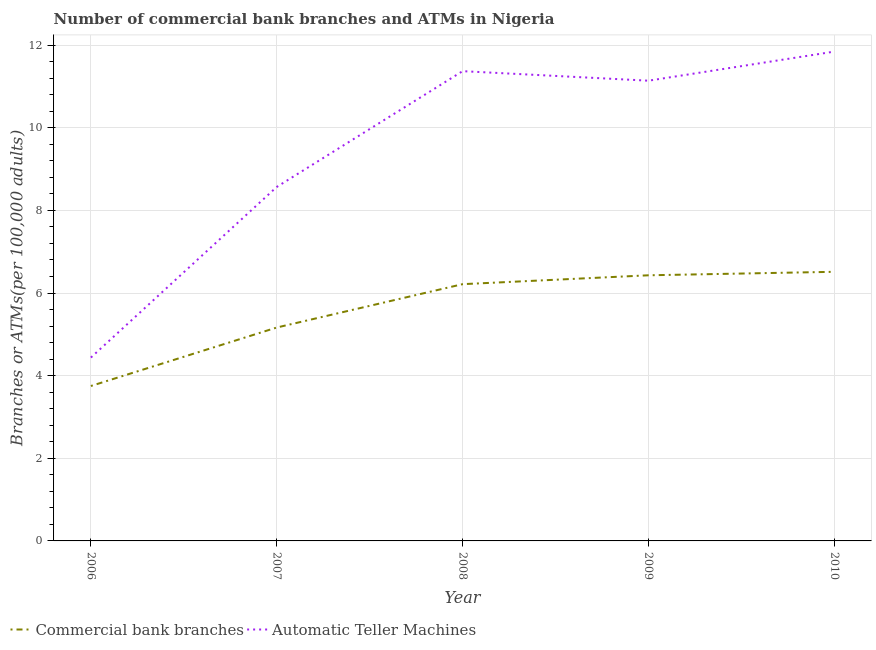Does the line corresponding to number of commercal bank branches intersect with the line corresponding to number of atms?
Offer a very short reply. No. What is the number of atms in 2006?
Your response must be concise. 4.44. Across all years, what is the maximum number of commercal bank branches?
Ensure brevity in your answer.  6.51. Across all years, what is the minimum number of commercal bank branches?
Make the answer very short. 3.75. In which year was the number of atms maximum?
Give a very brief answer. 2010. What is the total number of atms in the graph?
Your response must be concise. 47.36. What is the difference between the number of commercal bank branches in 2009 and that in 2010?
Provide a succinct answer. -0.08. What is the difference between the number of commercal bank branches in 2006 and the number of atms in 2008?
Make the answer very short. -7.62. What is the average number of atms per year?
Provide a succinct answer. 9.47. In the year 2007, what is the difference between the number of atms and number of commercal bank branches?
Ensure brevity in your answer.  3.4. What is the ratio of the number of commercal bank branches in 2007 to that in 2010?
Your response must be concise. 0.79. Is the difference between the number of atms in 2007 and 2009 greater than the difference between the number of commercal bank branches in 2007 and 2009?
Your answer should be compact. No. What is the difference between the highest and the second highest number of atms?
Your response must be concise. 0.47. What is the difference between the highest and the lowest number of atms?
Provide a short and direct response. 7.41. In how many years, is the number of commercal bank branches greater than the average number of commercal bank branches taken over all years?
Offer a very short reply. 3. Is the sum of the number of commercal bank branches in 2007 and 2008 greater than the maximum number of atms across all years?
Keep it short and to the point. No. Does the number of atms monotonically increase over the years?
Give a very brief answer. No. How many years are there in the graph?
Your answer should be very brief. 5. What is the difference between two consecutive major ticks on the Y-axis?
Provide a succinct answer. 2. How many legend labels are there?
Give a very brief answer. 2. How are the legend labels stacked?
Keep it short and to the point. Horizontal. What is the title of the graph?
Provide a short and direct response. Number of commercial bank branches and ATMs in Nigeria. What is the label or title of the Y-axis?
Offer a very short reply. Branches or ATMs(per 100,0 adults). What is the Branches or ATMs(per 100,000 adults) in Commercial bank branches in 2006?
Ensure brevity in your answer.  3.75. What is the Branches or ATMs(per 100,000 adults) in Automatic Teller Machines in 2006?
Offer a terse response. 4.44. What is the Branches or ATMs(per 100,000 adults) of Commercial bank branches in 2007?
Provide a short and direct response. 5.16. What is the Branches or ATMs(per 100,000 adults) in Automatic Teller Machines in 2007?
Offer a terse response. 8.57. What is the Branches or ATMs(per 100,000 adults) in Commercial bank branches in 2008?
Offer a very short reply. 6.21. What is the Branches or ATMs(per 100,000 adults) of Automatic Teller Machines in 2008?
Keep it short and to the point. 11.37. What is the Branches or ATMs(per 100,000 adults) in Commercial bank branches in 2009?
Make the answer very short. 6.43. What is the Branches or ATMs(per 100,000 adults) in Automatic Teller Machines in 2009?
Keep it short and to the point. 11.14. What is the Branches or ATMs(per 100,000 adults) in Commercial bank branches in 2010?
Ensure brevity in your answer.  6.51. What is the Branches or ATMs(per 100,000 adults) of Automatic Teller Machines in 2010?
Your answer should be compact. 11.84. Across all years, what is the maximum Branches or ATMs(per 100,000 adults) of Commercial bank branches?
Your answer should be very brief. 6.51. Across all years, what is the maximum Branches or ATMs(per 100,000 adults) of Automatic Teller Machines?
Ensure brevity in your answer.  11.84. Across all years, what is the minimum Branches or ATMs(per 100,000 adults) of Commercial bank branches?
Make the answer very short. 3.75. Across all years, what is the minimum Branches or ATMs(per 100,000 adults) in Automatic Teller Machines?
Offer a very short reply. 4.44. What is the total Branches or ATMs(per 100,000 adults) of Commercial bank branches in the graph?
Provide a succinct answer. 28.07. What is the total Branches or ATMs(per 100,000 adults) in Automatic Teller Machines in the graph?
Offer a terse response. 47.36. What is the difference between the Branches or ATMs(per 100,000 adults) of Commercial bank branches in 2006 and that in 2007?
Provide a short and direct response. -1.41. What is the difference between the Branches or ATMs(per 100,000 adults) in Automatic Teller Machines in 2006 and that in 2007?
Make the answer very short. -4.13. What is the difference between the Branches or ATMs(per 100,000 adults) of Commercial bank branches in 2006 and that in 2008?
Keep it short and to the point. -2.46. What is the difference between the Branches or ATMs(per 100,000 adults) in Automatic Teller Machines in 2006 and that in 2008?
Your response must be concise. -6.93. What is the difference between the Branches or ATMs(per 100,000 adults) in Commercial bank branches in 2006 and that in 2009?
Provide a succinct answer. -2.68. What is the difference between the Branches or ATMs(per 100,000 adults) in Automatic Teller Machines in 2006 and that in 2009?
Provide a short and direct response. -6.7. What is the difference between the Branches or ATMs(per 100,000 adults) of Commercial bank branches in 2006 and that in 2010?
Keep it short and to the point. -2.76. What is the difference between the Branches or ATMs(per 100,000 adults) of Automatic Teller Machines in 2006 and that in 2010?
Your answer should be very brief. -7.41. What is the difference between the Branches or ATMs(per 100,000 adults) in Commercial bank branches in 2007 and that in 2008?
Provide a succinct answer. -1.05. What is the difference between the Branches or ATMs(per 100,000 adults) in Automatic Teller Machines in 2007 and that in 2008?
Give a very brief answer. -2.8. What is the difference between the Branches or ATMs(per 100,000 adults) of Commercial bank branches in 2007 and that in 2009?
Make the answer very short. -1.26. What is the difference between the Branches or ATMs(per 100,000 adults) in Automatic Teller Machines in 2007 and that in 2009?
Make the answer very short. -2.57. What is the difference between the Branches or ATMs(per 100,000 adults) of Commercial bank branches in 2007 and that in 2010?
Your response must be concise. -1.35. What is the difference between the Branches or ATMs(per 100,000 adults) in Automatic Teller Machines in 2007 and that in 2010?
Offer a very short reply. -3.28. What is the difference between the Branches or ATMs(per 100,000 adults) of Commercial bank branches in 2008 and that in 2009?
Provide a short and direct response. -0.21. What is the difference between the Branches or ATMs(per 100,000 adults) of Automatic Teller Machines in 2008 and that in 2009?
Your response must be concise. 0.23. What is the difference between the Branches or ATMs(per 100,000 adults) of Commercial bank branches in 2008 and that in 2010?
Provide a succinct answer. -0.3. What is the difference between the Branches or ATMs(per 100,000 adults) in Automatic Teller Machines in 2008 and that in 2010?
Make the answer very short. -0.47. What is the difference between the Branches or ATMs(per 100,000 adults) in Commercial bank branches in 2009 and that in 2010?
Ensure brevity in your answer.  -0.08. What is the difference between the Branches or ATMs(per 100,000 adults) in Automatic Teller Machines in 2009 and that in 2010?
Provide a succinct answer. -0.7. What is the difference between the Branches or ATMs(per 100,000 adults) of Commercial bank branches in 2006 and the Branches or ATMs(per 100,000 adults) of Automatic Teller Machines in 2007?
Provide a short and direct response. -4.82. What is the difference between the Branches or ATMs(per 100,000 adults) in Commercial bank branches in 2006 and the Branches or ATMs(per 100,000 adults) in Automatic Teller Machines in 2008?
Provide a short and direct response. -7.62. What is the difference between the Branches or ATMs(per 100,000 adults) of Commercial bank branches in 2006 and the Branches or ATMs(per 100,000 adults) of Automatic Teller Machines in 2009?
Provide a short and direct response. -7.39. What is the difference between the Branches or ATMs(per 100,000 adults) in Commercial bank branches in 2006 and the Branches or ATMs(per 100,000 adults) in Automatic Teller Machines in 2010?
Offer a very short reply. -8.09. What is the difference between the Branches or ATMs(per 100,000 adults) in Commercial bank branches in 2007 and the Branches or ATMs(per 100,000 adults) in Automatic Teller Machines in 2008?
Offer a terse response. -6.2. What is the difference between the Branches or ATMs(per 100,000 adults) in Commercial bank branches in 2007 and the Branches or ATMs(per 100,000 adults) in Automatic Teller Machines in 2009?
Keep it short and to the point. -5.97. What is the difference between the Branches or ATMs(per 100,000 adults) in Commercial bank branches in 2007 and the Branches or ATMs(per 100,000 adults) in Automatic Teller Machines in 2010?
Your answer should be compact. -6.68. What is the difference between the Branches or ATMs(per 100,000 adults) of Commercial bank branches in 2008 and the Branches or ATMs(per 100,000 adults) of Automatic Teller Machines in 2009?
Provide a succinct answer. -4.92. What is the difference between the Branches or ATMs(per 100,000 adults) of Commercial bank branches in 2008 and the Branches or ATMs(per 100,000 adults) of Automatic Teller Machines in 2010?
Offer a terse response. -5.63. What is the difference between the Branches or ATMs(per 100,000 adults) of Commercial bank branches in 2009 and the Branches or ATMs(per 100,000 adults) of Automatic Teller Machines in 2010?
Ensure brevity in your answer.  -5.41. What is the average Branches or ATMs(per 100,000 adults) of Commercial bank branches per year?
Make the answer very short. 5.61. What is the average Branches or ATMs(per 100,000 adults) in Automatic Teller Machines per year?
Make the answer very short. 9.47. In the year 2006, what is the difference between the Branches or ATMs(per 100,000 adults) in Commercial bank branches and Branches or ATMs(per 100,000 adults) in Automatic Teller Machines?
Your response must be concise. -0.69. In the year 2007, what is the difference between the Branches or ATMs(per 100,000 adults) of Commercial bank branches and Branches or ATMs(per 100,000 adults) of Automatic Teller Machines?
Ensure brevity in your answer.  -3.4. In the year 2008, what is the difference between the Branches or ATMs(per 100,000 adults) of Commercial bank branches and Branches or ATMs(per 100,000 adults) of Automatic Teller Machines?
Your answer should be very brief. -5.16. In the year 2009, what is the difference between the Branches or ATMs(per 100,000 adults) in Commercial bank branches and Branches or ATMs(per 100,000 adults) in Automatic Teller Machines?
Make the answer very short. -4.71. In the year 2010, what is the difference between the Branches or ATMs(per 100,000 adults) of Commercial bank branches and Branches or ATMs(per 100,000 adults) of Automatic Teller Machines?
Your answer should be very brief. -5.33. What is the ratio of the Branches or ATMs(per 100,000 adults) of Commercial bank branches in 2006 to that in 2007?
Offer a terse response. 0.73. What is the ratio of the Branches or ATMs(per 100,000 adults) of Automatic Teller Machines in 2006 to that in 2007?
Provide a short and direct response. 0.52. What is the ratio of the Branches or ATMs(per 100,000 adults) of Commercial bank branches in 2006 to that in 2008?
Offer a terse response. 0.6. What is the ratio of the Branches or ATMs(per 100,000 adults) of Automatic Teller Machines in 2006 to that in 2008?
Offer a terse response. 0.39. What is the ratio of the Branches or ATMs(per 100,000 adults) of Commercial bank branches in 2006 to that in 2009?
Give a very brief answer. 0.58. What is the ratio of the Branches or ATMs(per 100,000 adults) of Automatic Teller Machines in 2006 to that in 2009?
Give a very brief answer. 0.4. What is the ratio of the Branches or ATMs(per 100,000 adults) in Commercial bank branches in 2006 to that in 2010?
Ensure brevity in your answer.  0.58. What is the ratio of the Branches or ATMs(per 100,000 adults) in Automatic Teller Machines in 2006 to that in 2010?
Keep it short and to the point. 0.37. What is the ratio of the Branches or ATMs(per 100,000 adults) of Commercial bank branches in 2007 to that in 2008?
Keep it short and to the point. 0.83. What is the ratio of the Branches or ATMs(per 100,000 adults) in Automatic Teller Machines in 2007 to that in 2008?
Provide a short and direct response. 0.75. What is the ratio of the Branches or ATMs(per 100,000 adults) of Commercial bank branches in 2007 to that in 2009?
Provide a succinct answer. 0.8. What is the ratio of the Branches or ATMs(per 100,000 adults) of Automatic Teller Machines in 2007 to that in 2009?
Your answer should be compact. 0.77. What is the ratio of the Branches or ATMs(per 100,000 adults) in Commercial bank branches in 2007 to that in 2010?
Your answer should be compact. 0.79. What is the ratio of the Branches or ATMs(per 100,000 adults) of Automatic Teller Machines in 2007 to that in 2010?
Provide a succinct answer. 0.72. What is the ratio of the Branches or ATMs(per 100,000 adults) of Commercial bank branches in 2008 to that in 2009?
Provide a succinct answer. 0.97. What is the ratio of the Branches or ATMs(per 100,000 adults) of Automatic Teller Machines in 2008 to that in 2009?
Provide a short and direct response. 1.02. What is the ratio of the Branches or ATMs(per 100,000 adults) in Commercial bank branches in 2008 to that in 2010?
Give a very brief answer. 0.95. What is the ratio of the Branches or ATMs(per 100,000 adults) of Commercial bank branches in 2009 to that in 2010?
Provide a succinct answer. 0.99. What is the ratio of the Branches or ATMs(per 100,000 adults) of Automatic Teller Machines in 2009 to that in 2010?
Ensure brevity in your answer.  0.94. What is the difference between the highest and the second highest Branches or ATMs(per 100,000 adults) of Commercial bank branches?
Offer a terse response. 0.08. What is the difference between the highest and the second highest Branches or ATMs(per 100,000 adults) of Automatic Teller Machines?
Make the answer very short. 0.47. What is the difference between the highest and the lowest Branches or ATMs(per 100,000 adults) of Commercial bank branches?
Provide a succinct answer. 2.76. What is the difference between the highest and the lowest Branches or ATMs(per 100,000 adults) in Automatic Teller Machines?
Your answer should be very brief. 7.41. 